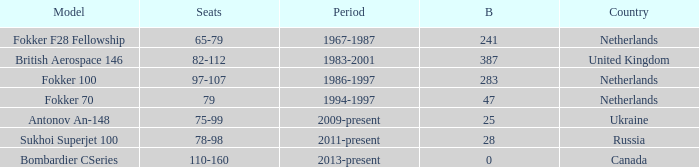How many cabins were built in the time between 1967-1987? 241.0. 